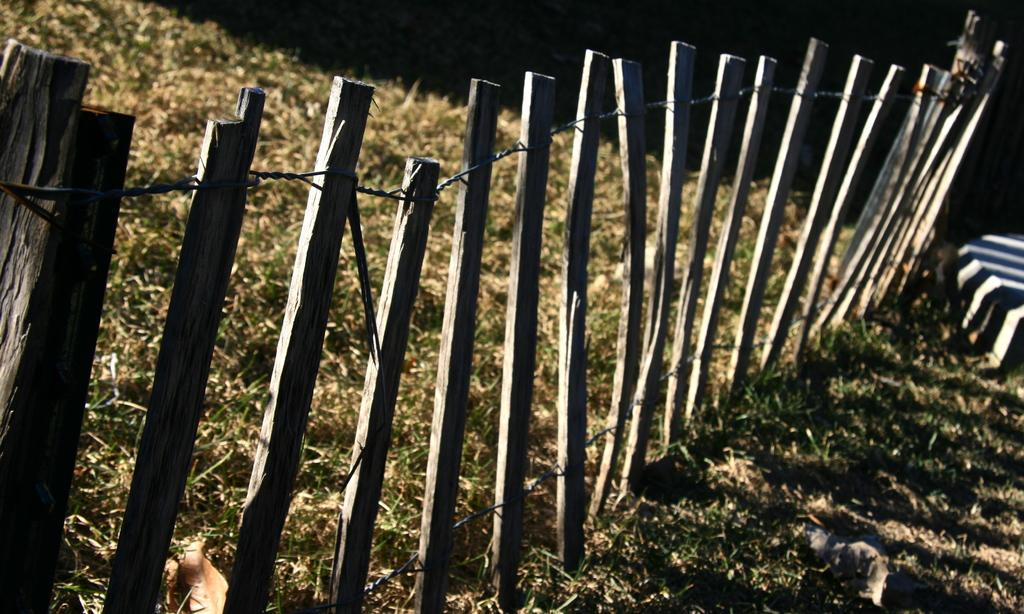What is the main structure visible in the image? There is a fence in the image. What type of ground surface can be seen in the image? There is grass on the ground in the image. How would you describe the lighting in the image? The background of the image is dark. What type of iron is being used to start a fire in the image? There is no iron or fire present in the image; it only features a fence and grass. 